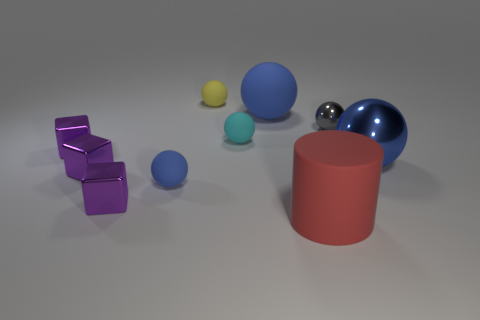Is the color of the cylinder the same as the big metal object?
Ensure brevity in your answer.  No. Are the big red cylinder that is in front of the yellow ball and the big sphere that is to the left of the big red matte thing made of the same material?
Ensure brevity in your answer.  Yes. Is the number of big red spheres greater than the number of big blue spheres?
Your answer should be compact. No. Are there any other things that have the same color as the big cylinder?
Your answer should be compact. No. Do the cyan ball and the tiny yellow ball have the same material?
Offer a terse response. Yes. Are there fewer large things than big blue shiny balls?
Provide a succinct answer. No. Is the small yellow matte thing the same shape as the blue metallic thing?
Offer a terse response. Yes. The rubber cylinder has what color?
Your response must be concise. Red. What number of other things are there of the same material as the big red cylinder
Your answer should be very brief. 4. What number of green objects are either big rubber cylinders or rubber spheres?
Your answer should be compact. 0. 